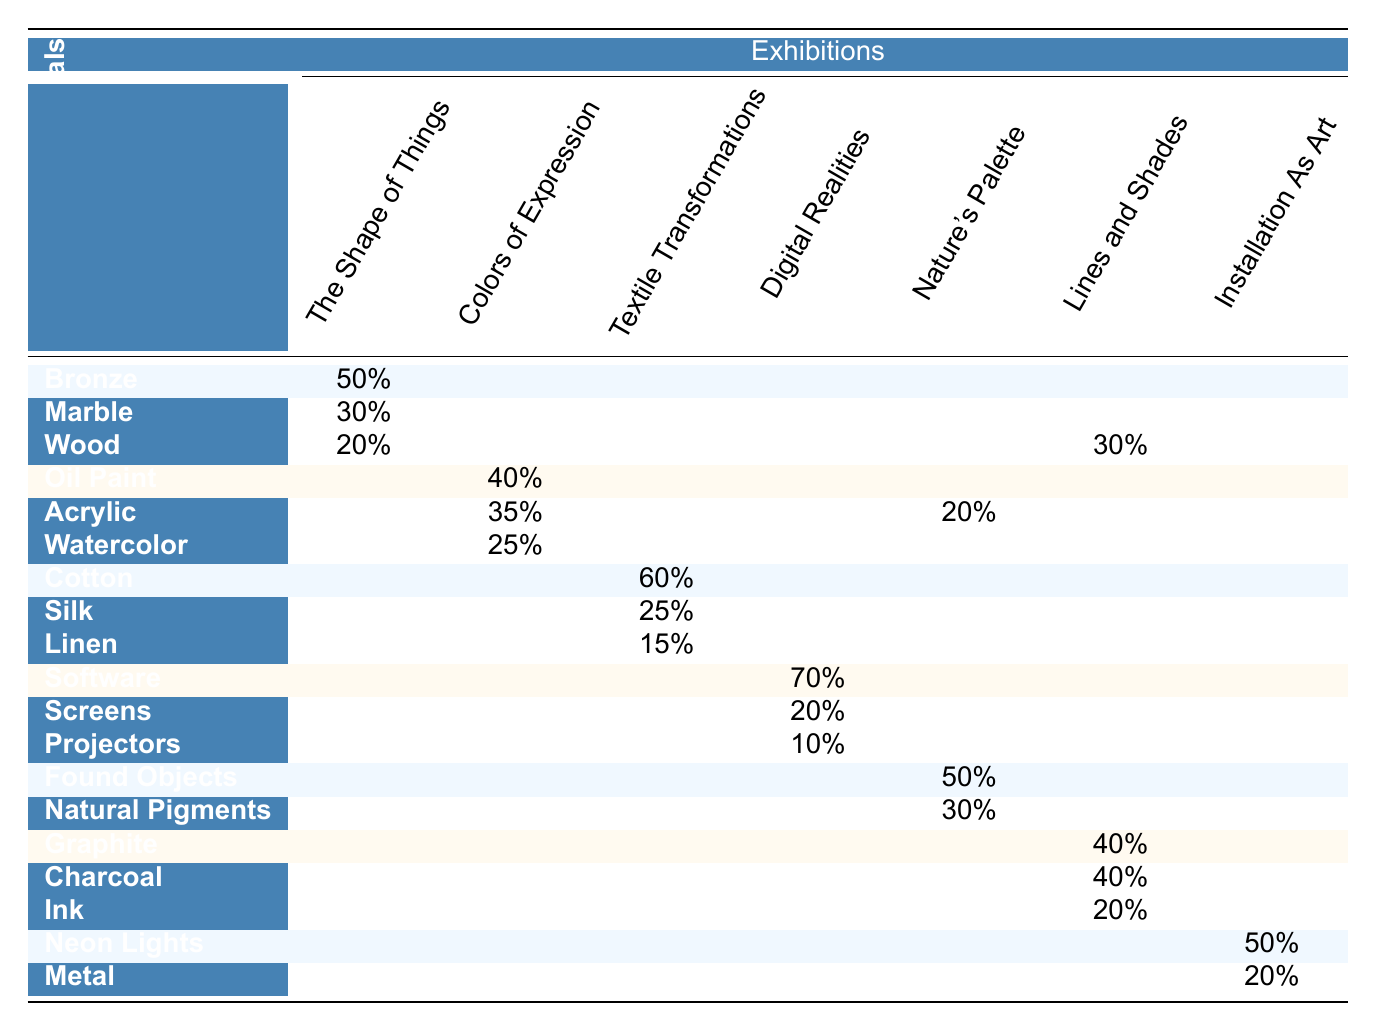What percentage of materials used in "The Shape of Things" is attributed to Bronze? The table shows that for "The Shape of Things", Bronze accounts for 50% of the materials used.
Answer: 50% Which exhibition used the highest percentage of Oil Paint? According to the table, "Colors of Expression" used Oil Paint which has a usage of 40%. This is the only exhibition listed for Oil Paint, therefore it is the highest.
Answer: 40% What is the total percentage of materials used in "Textile Transformations"? The table lists Cotton (60%), Silk (25%), and Linen (15%) for "Textile Transformations". Summing these gives 60 + 25 + 15 = 100%.
Answer: 100% Is it true that "Installation As Art" used Wood in its materials? The table indicates that "Installation As Art" includes Wood, which is noted with a usage of 30%. Therefore, this statement is true.
Answer: Yes Which medium had the highest single material usage across all exhibitions? The usage percentages indicate that Software in "Digital Realities" has the highest single material usage at 70%, surpassing other materials.
Answer: 70% What is the average percentage of Acrylic usage in the exhibitions listed? Acrylic is used in "Colors of Expression" (35%) and "Nature's Palette" (20%). Summing these gives 35 + 20 = 55%. Then, dividing by the number of exhibitions that include Acrylic (2) results in an average of 27.5%.
Answer: 27.5% Which exhibition had the same percentage usage for Graphite and Charcoal? Both Graphite and Charcoal show a usage of 40% in "Lines and Shades". This is the only exhibition listed where their percentages are equal.
Answer: Lines and Shades If we compare the total percentages of materials used in "Nature's Palette" to "Lines and Shades", which exhibition has a higher total? In "Nature's Palette", the overall usage is 50% for Found Objects, 30% for Natural Pigments, and 20% for Acrylic, totaling 100%. For "Lines and Shades", Graphite (40%), Charcoal (40%), and Ink (20%) sum to 100% as well. Both exhibitions have equal total percentages.
Answer: They are equal What percentage of materials used in "Digital Realities" is attributed to Projectors? The table specifies that Projectors make up 10% of the materials used in "Digital Realities".
Answer: 10% Which medium had the least usage of a single material across all exhibitions? The smallest value in the table is 10% for Projectors in "Digital Realities", making it the material with the least usage in a single exhibition.
Answer: 10% 